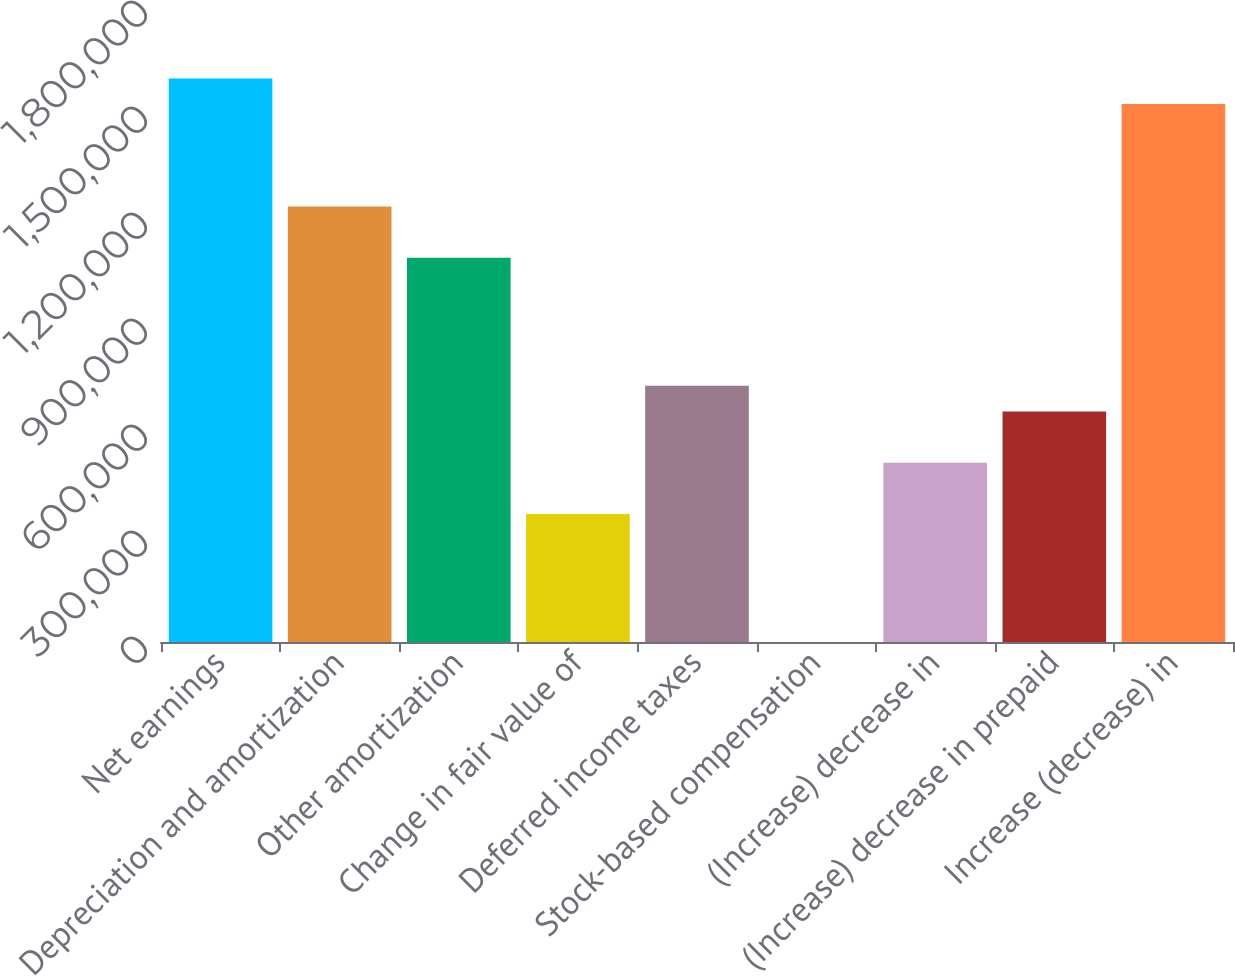Convert chart. <chart><loc_0><loc_0><loc_500><loc_500><bar_chart><fcel>Net earnings<fcel>Depreciation and amortization<fcel>Other amortization<fcel>Change in fair value of<fcel>Deferred income taxes<fcel>Stock-based compensation<fcel>(Increase) decrease in<fcel>(Increase) decrease in prepaid<fcel>Increase (decrease) in<nl><fcel>1.59484e+06<fcel>1.23241e+06<fcel>1.08743e+06<fcel>362570<fcel>725002<fcel>138<fcel>507543<fcel>652516<fcel>1.52235e+06<nl></chart> 